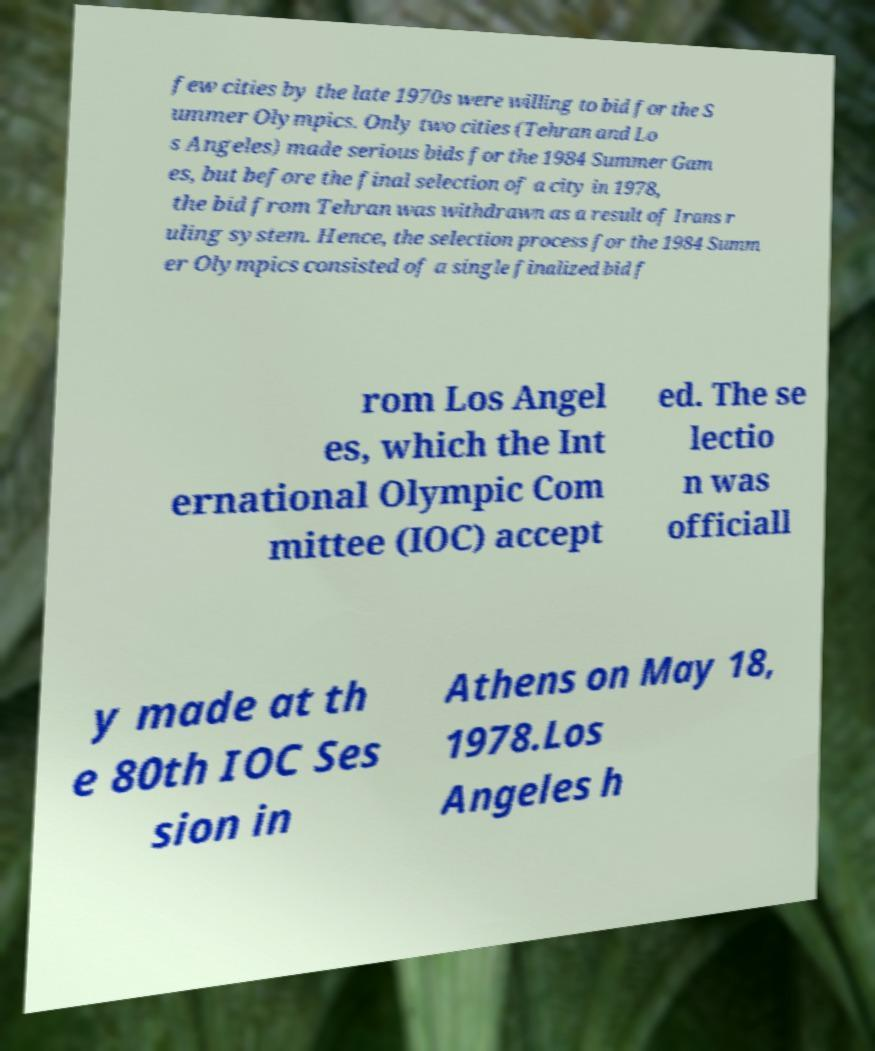Can you read and provide the text displayed in the image?This photo seems to have some interesting text. Can you extract and type it out for me? few cities by the late 1970s were willing to bid for the S ummer Olympics. Only two cities (Tehran and Lo s Angeles) made serious bids for the 1984 Summer Gam es, but before the final selection of a city in 1978, the bid from Tehran was withdrawn as a result of Irans r uling system. Hence, the selection process for the 1984 Summ er Olympics consisted of a single finalized bid f rom Los Angel es, which the Int ernational Olympic Com mittee (IOC) accept ed. The se lectio n was officiall y made at th e 80th IOC Ses sion in Athens on May 18, 1978.Los Angeles h 